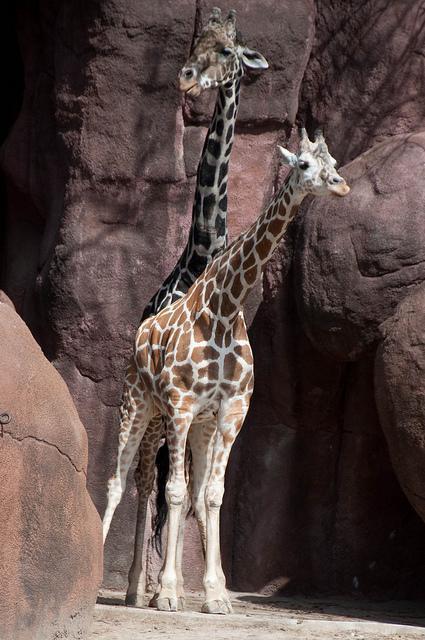How many animals are in this picture?
Give a very brief answer. 2. How many giraffes are there?
Give a very brief answer. 2. 